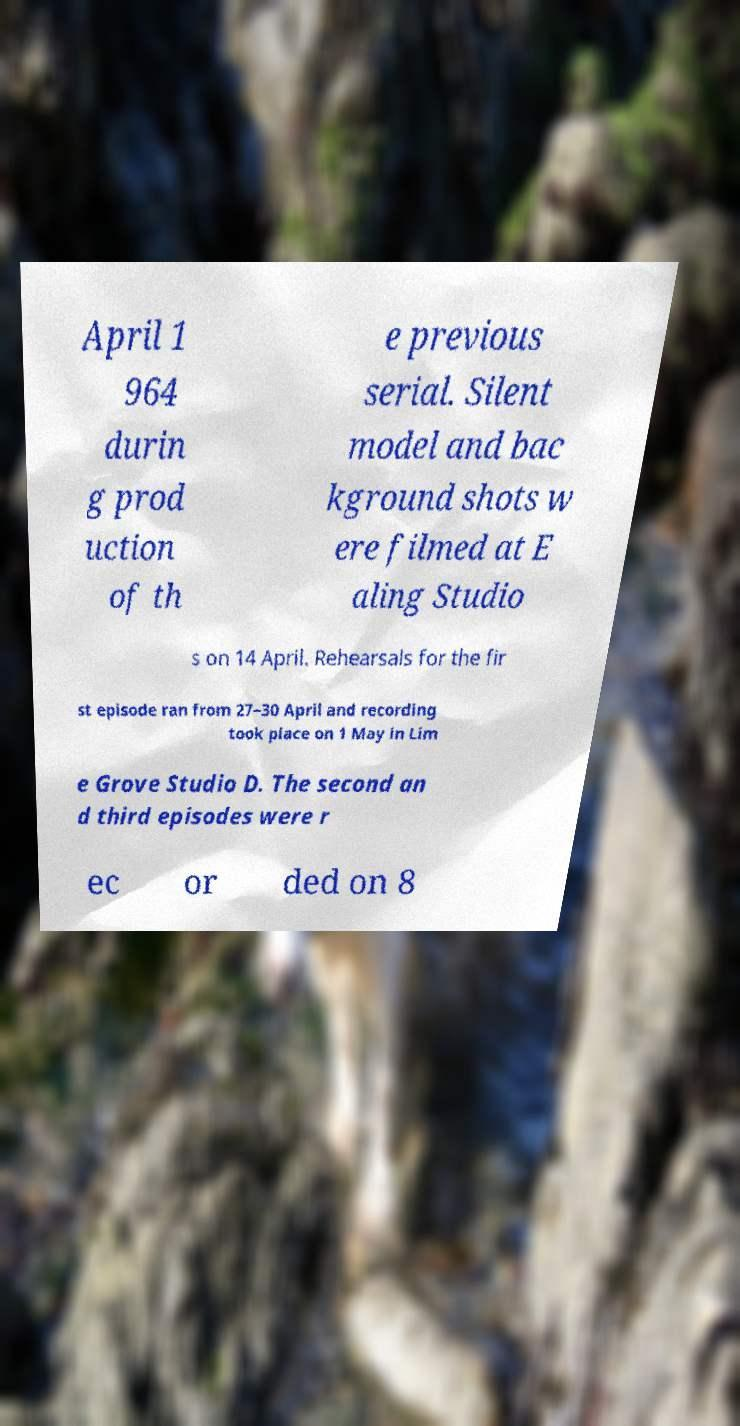Please read and relay the text visible in this image. What does it say? April 1 964 durin g prod uction of th e previous serial. Silent model and bac kground shots w ere filmed at E aling Studio s on 14 April. Rehearsals for the fir st episode ran from 27–30 April and recording took place on 1 May in Lim e Grove Studio D. The second an d third episodes were r ec or ded on 8 